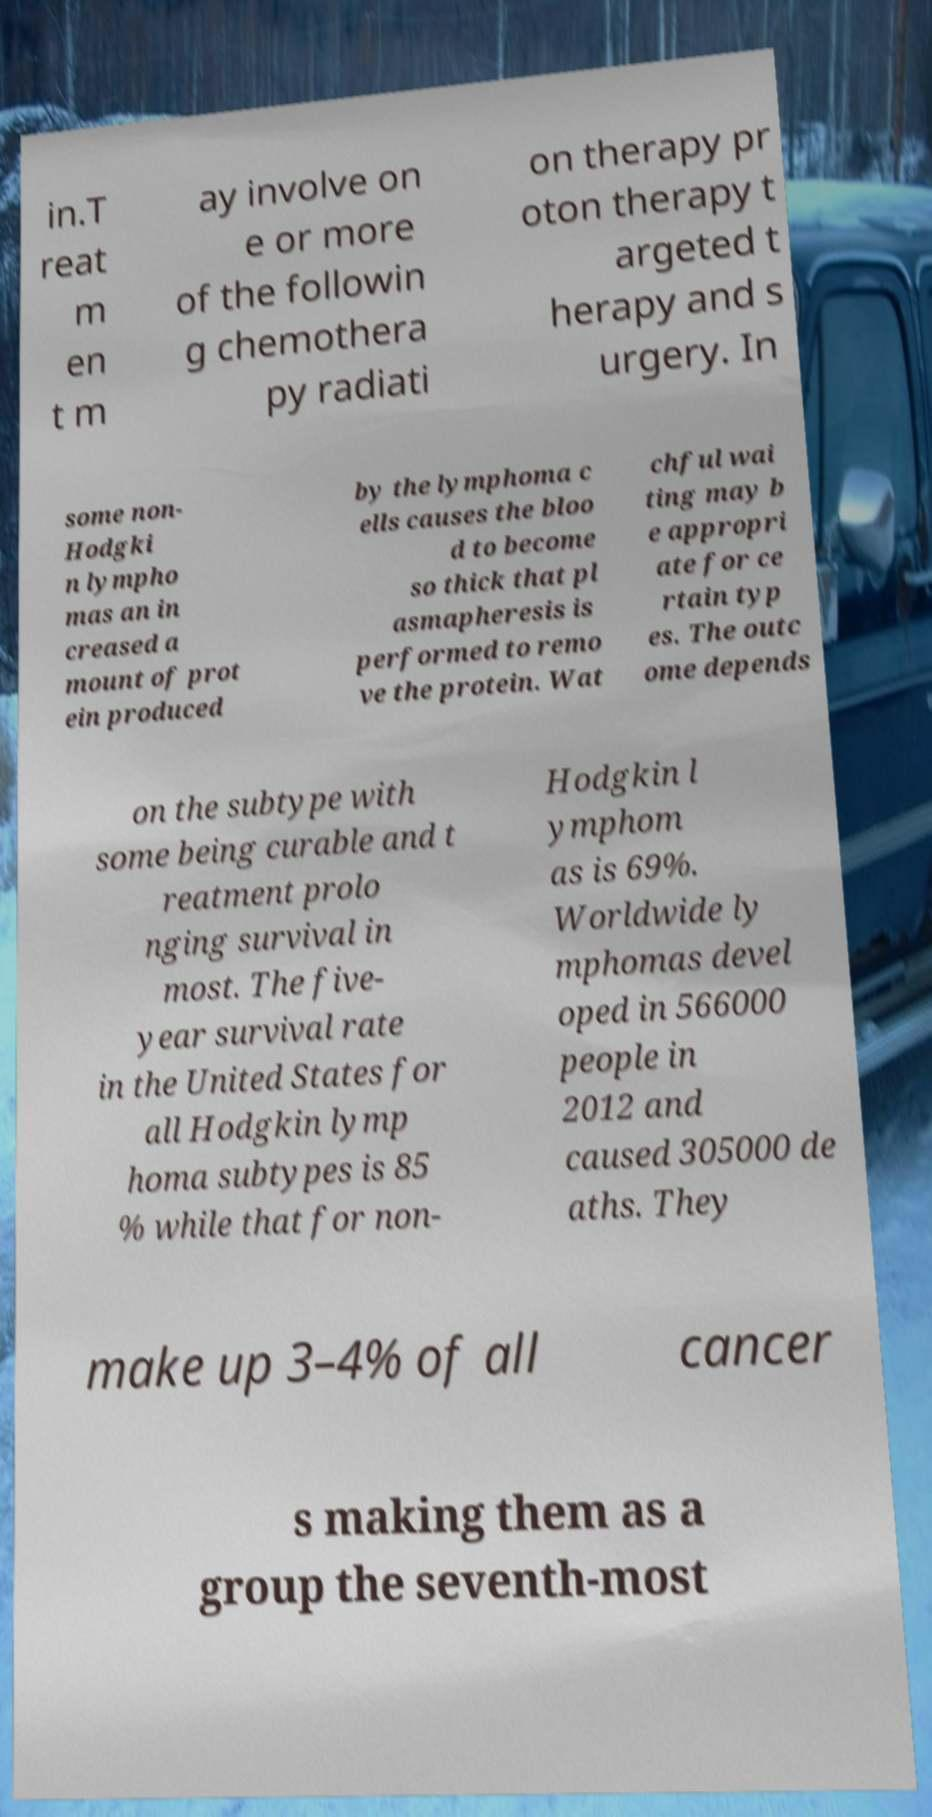Could you assist in decoding the text presented in this image and type it out clearly? in.T reat m en t m ay involve on e or more of the followin g chemothera py radiati on therapy pr oton therapy t argeted t herapy and s urgery. In some non- Hodgki n lympho mas an in creased a mount of prot ein produced by the lymphoma c ells causes the bloo d to become so thick that pl asmapheresis is performed to remo ve the protein. Wat chful wai ting may b e appropri ate for ce rtain typ es. The outc ome depends on the subtype with some being curable and t reatment prolo nging survival in most. The five- year survival rate in the United States for all Hodgkin lymp homa subtypes is 85 % while that for non- Hodgkin l ymphom as is 69%. Worldwide ly mphomas devel oped in 566000 people in 2012 and caused 305000 de aths. They make up 3–4% of all cancer s making them as a group the seventh-most 